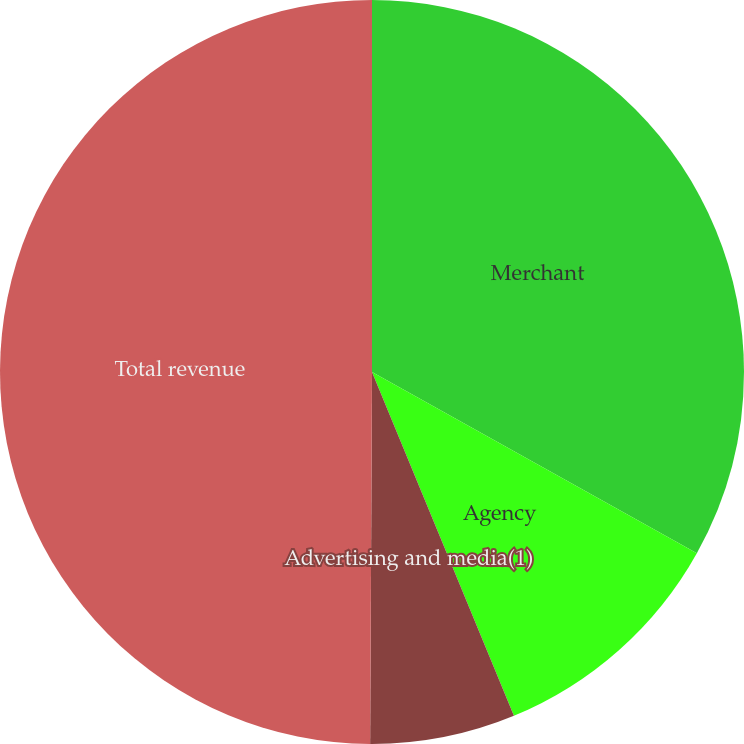Convert chart. <chart><loc_0><loc_0><loc_500><loc_500><pie_chart><fcel>Merchant<fcel>Agency<fcel>Advertising and media(1)<fcel>Total revenue<nl><fcel>33.1%<fcel>10.67%<fcel>6.31%<fcel>49.92%<nl></chart> 